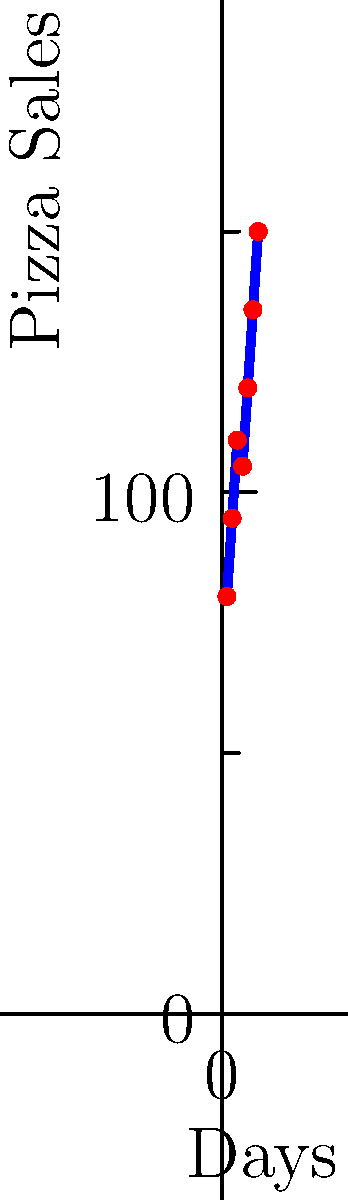Based on the line graph showing daily pizza sales for the past week, what is the predicted number of pizzas that will be sold on day 8 if the trend continues? To predict the sales for day 8, we need to analyze the trend in the given data:

1. Calculate the daily increase in sales:
   Day 1 to 2: 95 - 80 = 15
   Day 2 to 3: 110 - 95 = 15
   Day 3 to 4: 105 - 110 = -5 (slight decrease)
   Day 4 to 5: 120 - 105 = 15
   Day 5 to 6: 135 - 120 = 15
   Day 6 to 7: 150 - 135 = 15

2. Observe that the daily increase is consistently 15 pizzas, except for the slight dip between days 3 and 4.

3. Calculate the average daily increase:
   $\frac{15 + 15 - 5 + 15 + 15 + 15}{6} = \frac{70}{6} \approx 11.67$ pizzas per day

4. To be more accurate, we can use the overall trend from day 1 to day 7:
   $(150 - 80) \div 6 = 70 \div 6 \approx 11.67$ pizzas per day

5. Predict the sales for day 8:
   Day 7 sales + Average daily increase = 150 + 11.67 = 161.67

6. Round to the nearest whole number, as we can't sell partial pizzas.

Therefore, the predicted number of pizzas to be sold on day 8 is 162.
Answer: 162 pizzas 